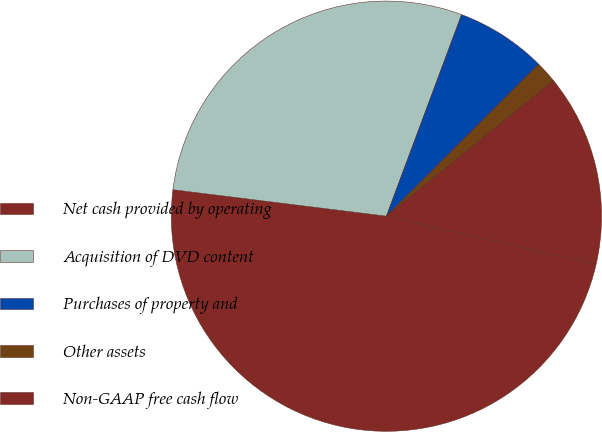Convert chart. <chart><loc_0><loc_0><loc_500><loc_500><pie_chart><fcel>Net cash provided by operating<fcel>Acquisition of DVD content<fcel>Purchases of property and<fcel>Other assets<fcel>Non-GAAP free cash flow<nl><fcel>48.36%<fcel>28.72%<fcel>6.83%<fcel>1.64%<fcel>14.45%<nl></chart> 